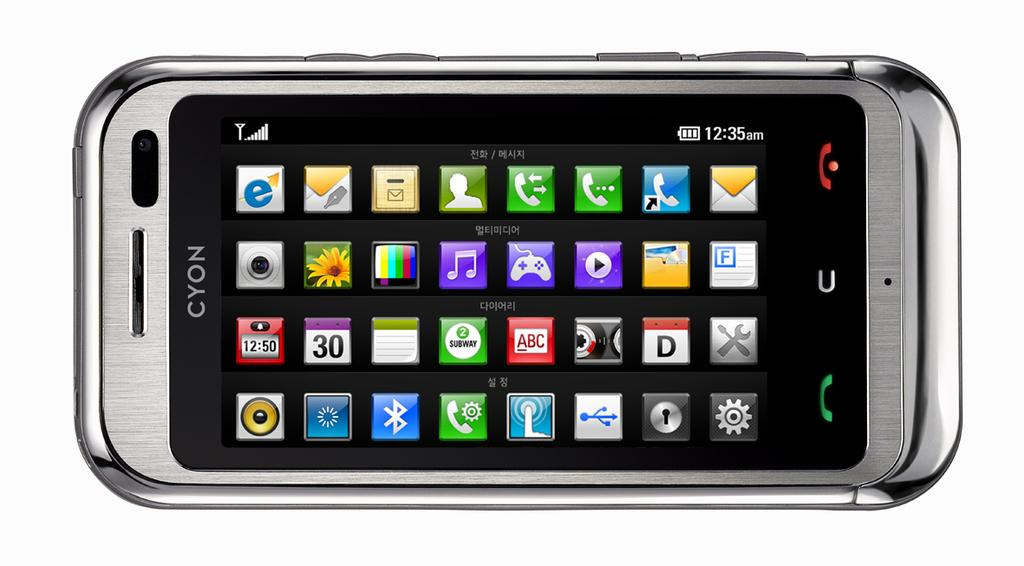<image>
Offer a succinct explanation of the picture presented. CYON Smartphone with lots of apps and full battery that says 12:35 AM. 